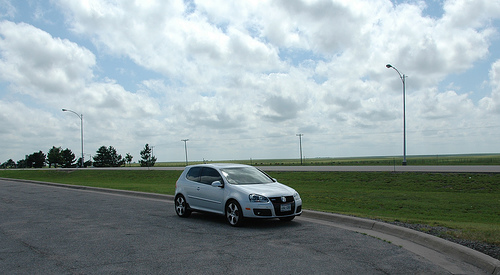<image>
Is the trees next to the lamppost? No. The trees is not positioned next to the lamppost. They are located in different areas of the scene. 